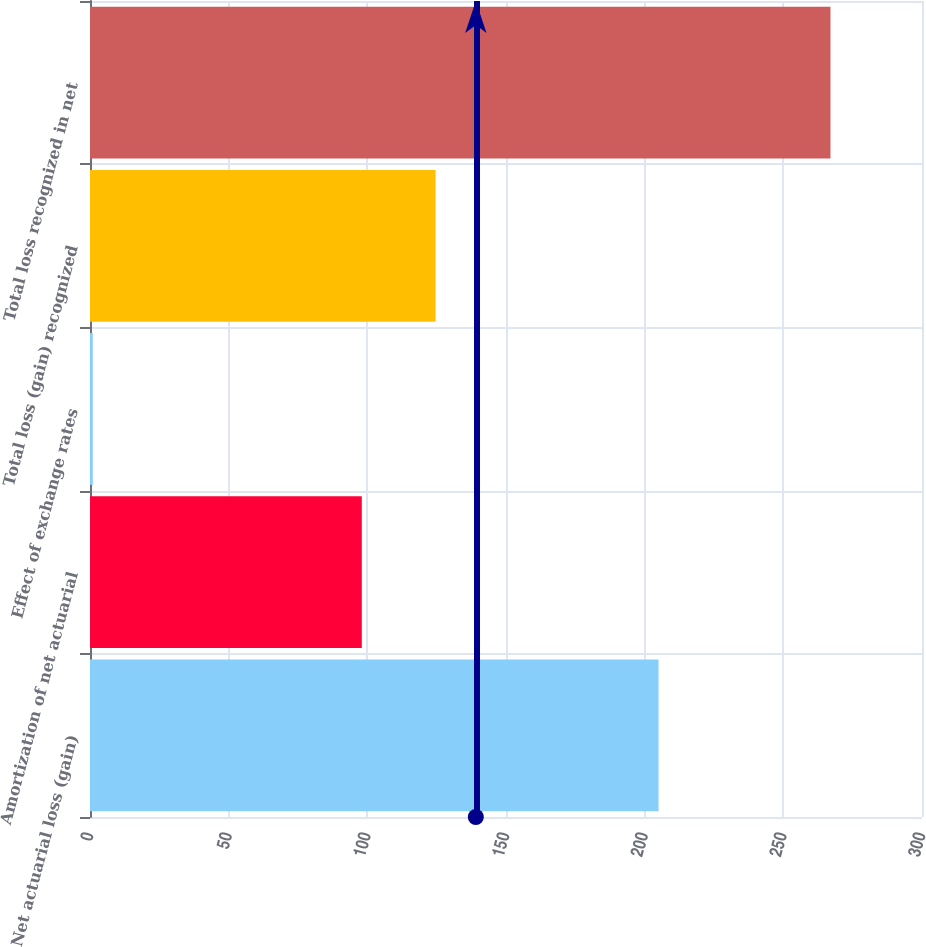<chart> <loc_0><loc_0><loc_500><loc_500><bar_chart><fcel>Net actuarial loss (gain)<fcel>Amortization of net actuarial<fcel>Effect of exchange rates<fcel>Total loss (gain) recognized<fcel>Total loss recognized in net<nl><fcel>205<fcel>98<fcel>1<fcel>124.6<fcel>267<nl></chart> 